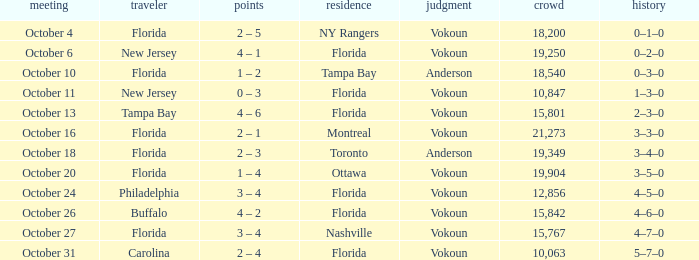What was the score on October 13? 4 – 6. 